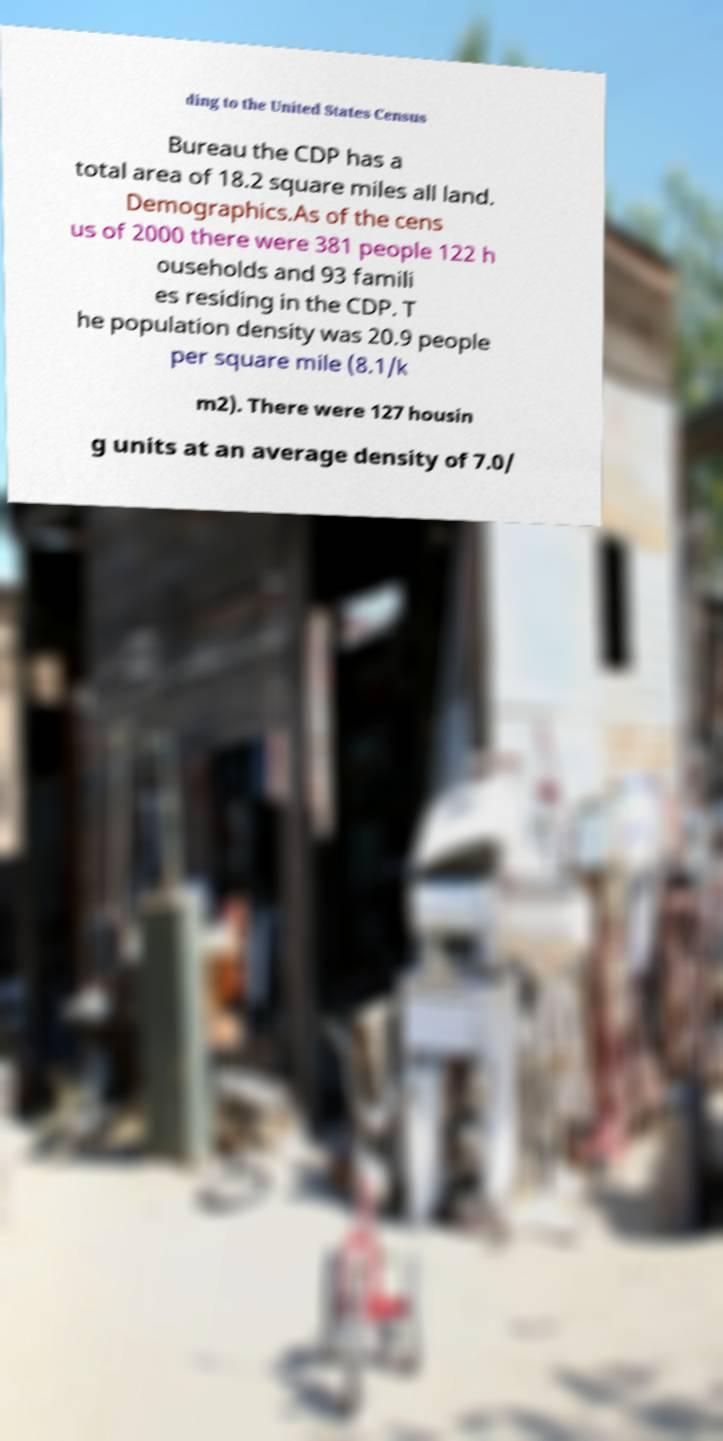Can you accurately transcribe the text from the provided image for me? ding to the United States Census Bureau the CDP has a total area of 18.2 square miles all land. Demographics.As of the cens us of 2000 there were 381 people 122 h ouseholds and 93 famili es residing in the CDP. T he population density was 20.9 people per square mile (8.1/k m2). There were 127 housin g units at an average density of 7.0/ 